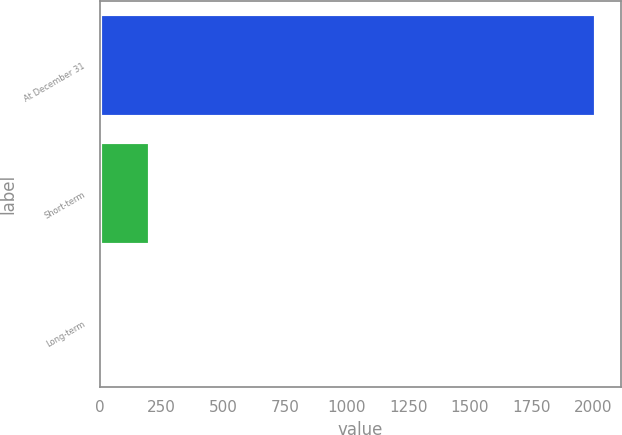<chart> <loc_0><loc_0><loc_500><loc_500><bar_chart><fcel>At December 31<fcel>Short-term<fcel>Long-term<nl><fcel>2012<fcel>204.04<fcel>3.16<nl></chart> 